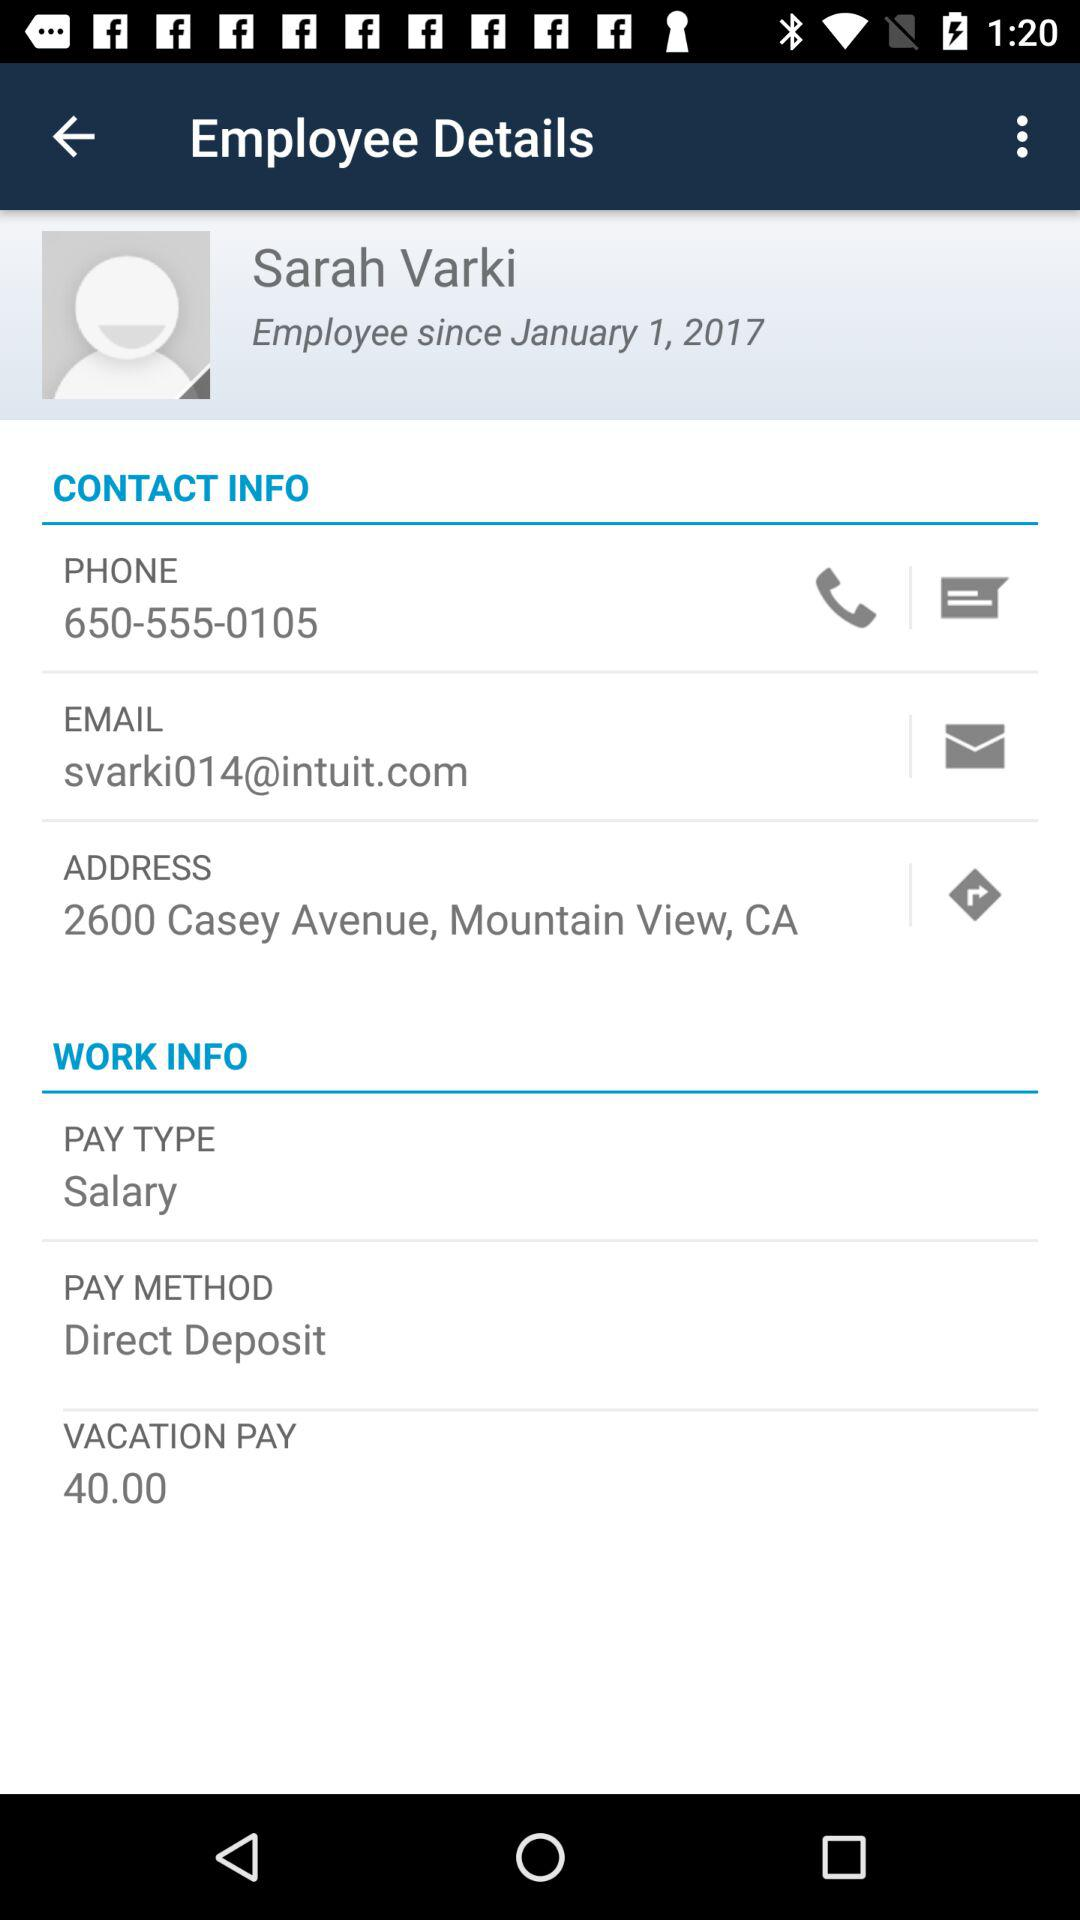What is the pay type? The pay type is salary. 